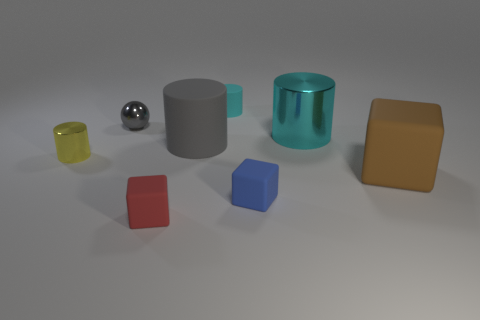Is the big cylinder on the left side of the large cyan object made of the same material as the cyan object that is to the right of the cyan rubber object? Based on the reflections and the appearance in the image, the big cylinder and the cyan object on the right seem to be made of different materials. The large cylinder on the left has a matte finish, suggesting a more porous surface, whereas the cyan object to its right exhibits a reflective surface, indicating it could be made of a smoother, potentially plastic material. 